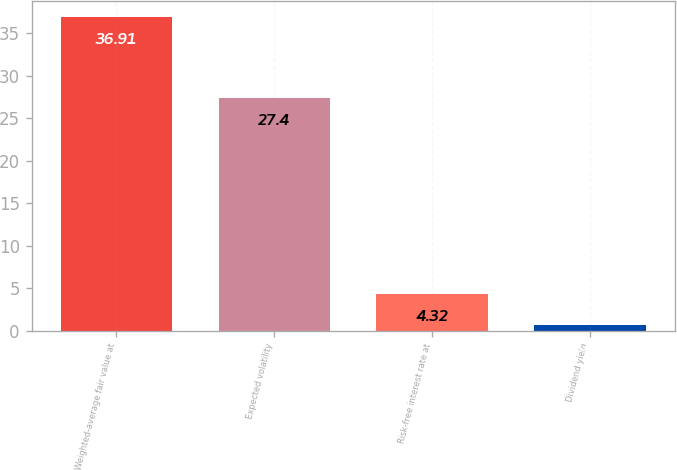Convert chart to OTSL. <chart><loc_0><loc_0><loc_500><loc_500><bar_chart><fcel>Weighted-average fair value at<fcel>Expected volatility<fcel>Risk-free interest rate at<fcel>Dividend yield<nl><fcel>36.91<fcel>27.4<fcel>4.32<fcel>0.7<nl></chart> 